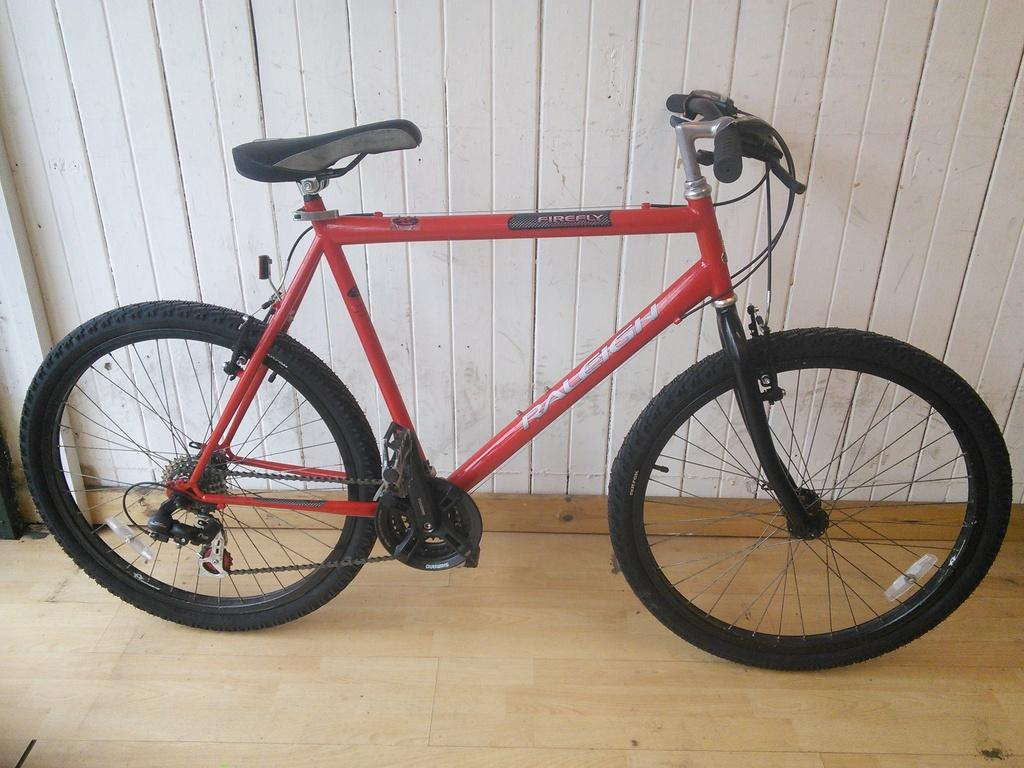What is the main object in the image? There is a bicycle in the image. What type of surface is the bicycle resting on? The bicycle is on a wooden floor. What can be seen behind the bicycle in the image? There is a white wall in the background of the image. What type of engine is powering the bicycle in the image? There is no engine present in the image, as bicycles are typically powered by human pedaling. 